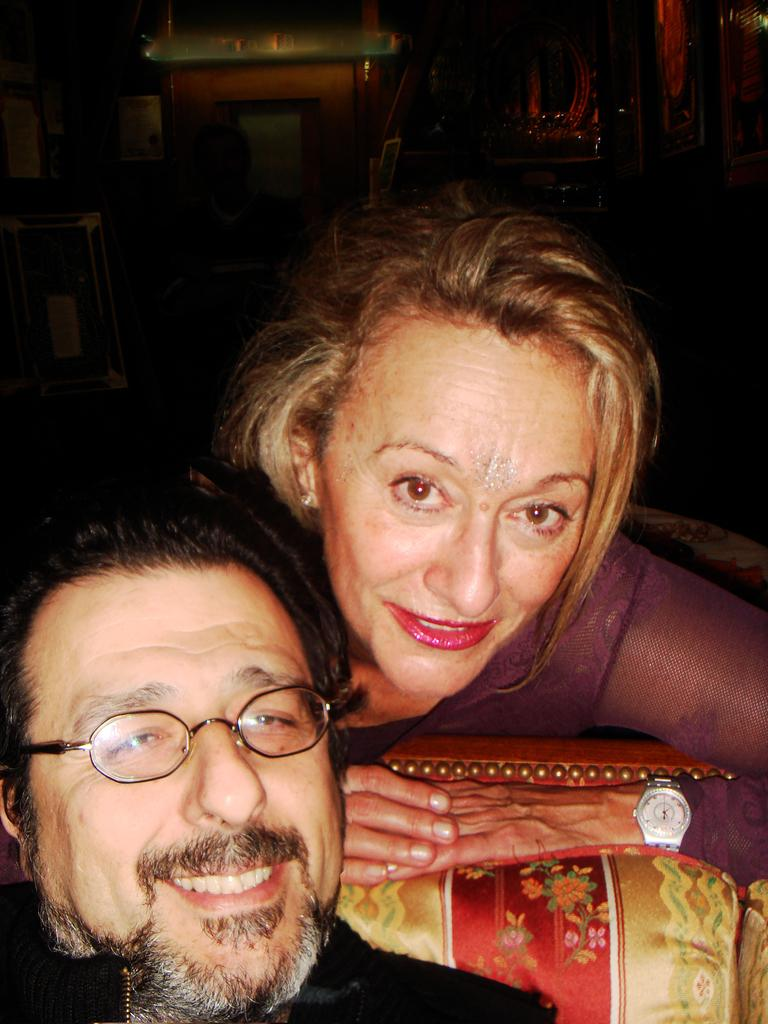How many people are present in the image? There are two people in the image, a man and a woman. What are the man and the woman doing in the image? Both the man and the woman are lying down. What can be observed about the man's appearance in the image? The man is wearing spectacles. What expressions do the man and the woman have in the image? Both the man and the woman are smiling. What type of underwear is the man wearing in the image? There is no information about the man's underwear in the image, so it cannot be determined. Can you tell me how many horses are present in the image? There are no horses present in the image. 